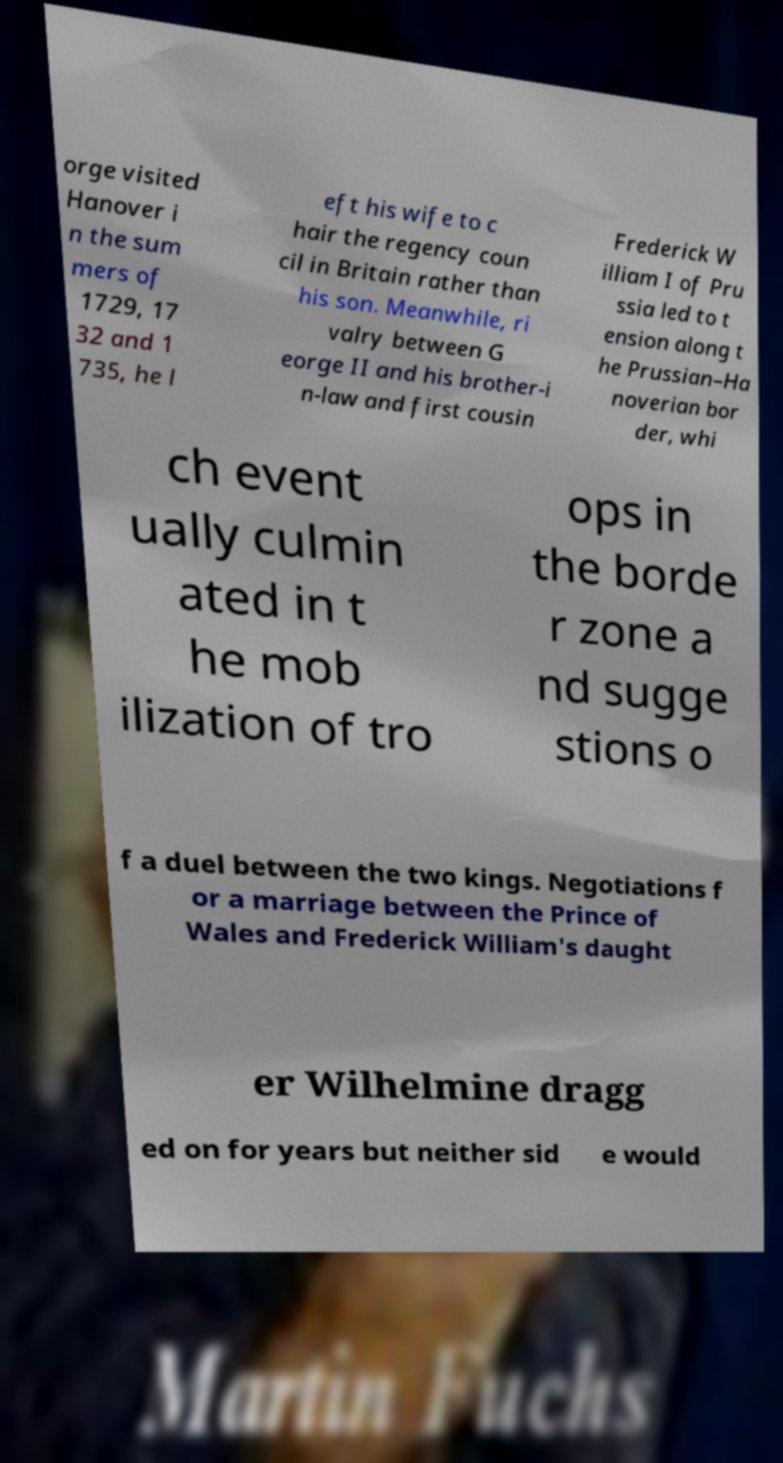Please read and relay the text visible in this image. What does it say? orge visited Hanover i n the sum mers of 1729, 17 32 and 1 735, he l eft his wife to c hair the regency coun cil in Britain rather than his son. Meanwhile, ri valry between G eorge II and his brother-i n-law and first cousin Frederick W illiam I of Pru ssia led to t ension along t he Prussian–Ha noverian bor der, whi ch event ually culmin ated in t he mob ilization of tro ops in the borde r zone a nd sugge stions o f a duel between the two kings. Negotiations f or a marriage between the Prince of Wales and Frederick William's daught er Wilhelmine dragg ed on for years but neither sid e would 